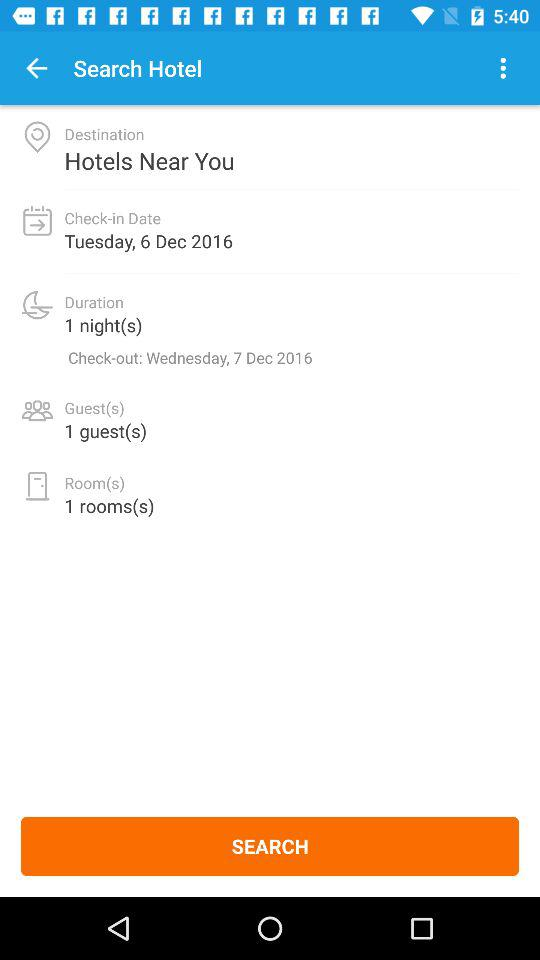How many days are there between the check-in and check-out dates?
Answer the question using a single word or phrase. 1 